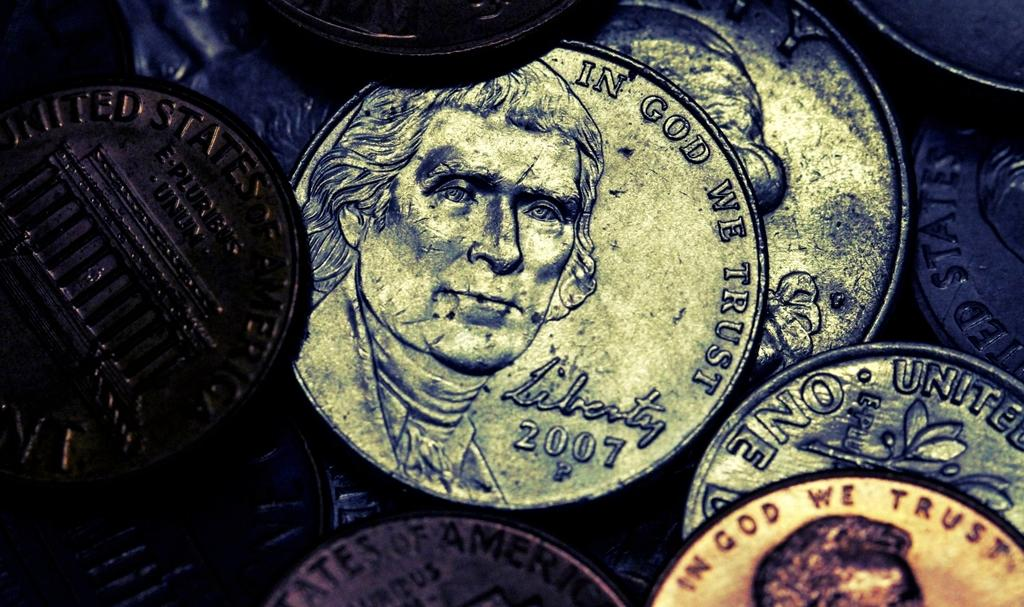<image>
Create a compact narrative representing the image presented. Some coins with In God We Trust written around the edge 